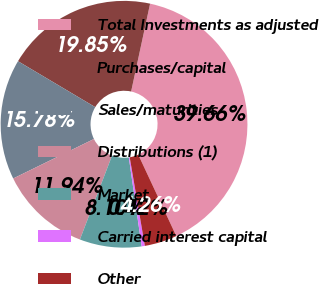Convert chart to OTSL. <chart><loc_0><loc_0><loc_500><loc_500><pie_chart><fcel>Total Investments as adjusted<fcel>Purchases/capital<fcel>Sales/maturities<fcel>Distributions (1)<fcel>Market<fcel>Carried interest capital<fcel>Other<nl><fcel>39.66%<fcel>19.85%<fcel>15.78%<fcel>11.94%<fcel>8.1%<fcel>0.42%<fcel>4.26%<nl></chart> 